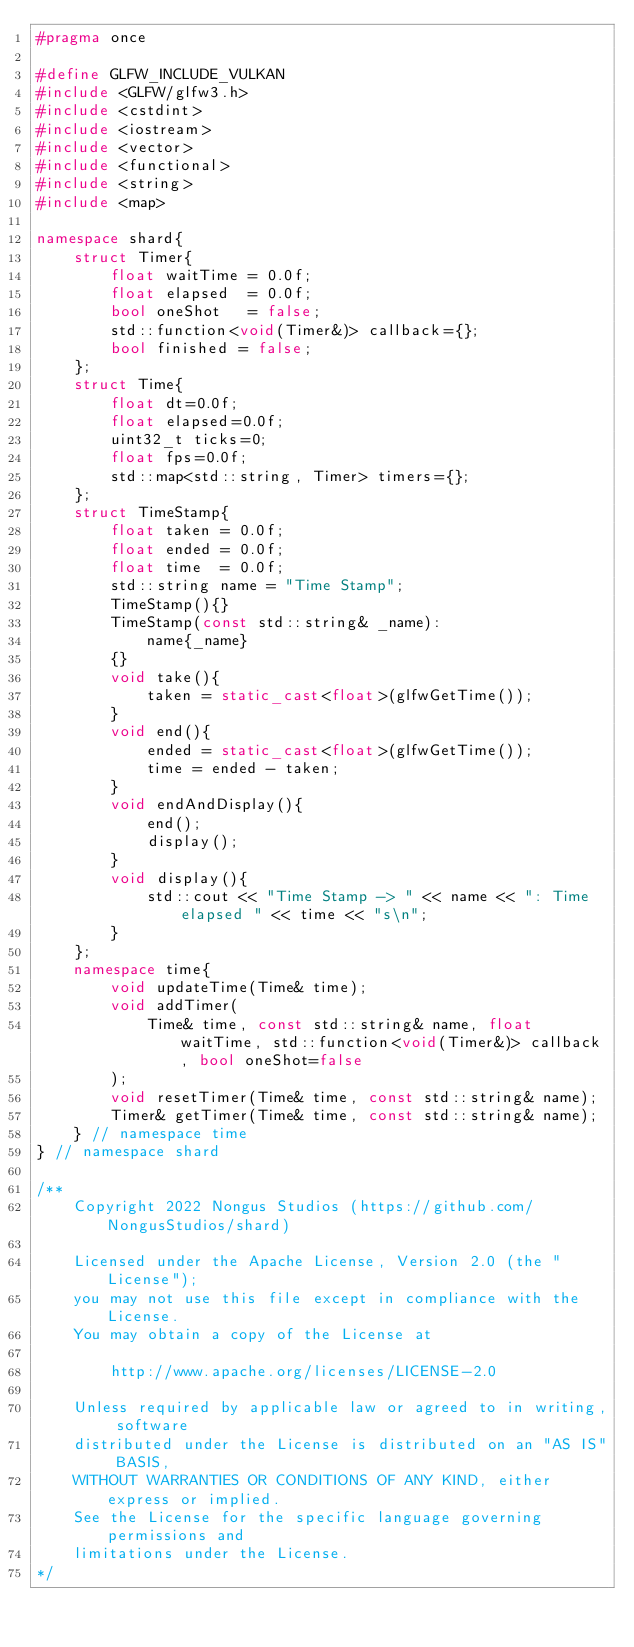Convert code to text. <code><loc_0><loc_0><loc_500><loc_500><_C++_>#pragma once

#define GLFW_INCLUDE_VULKAN
#include <GLFW/glfw3.h>
#include <cstdint>
#include <iostream>
#include <vector>
#include <functional>
#include <string>
#include <map>

namespace shard{
    struct Timer{
        float waitTime = 0.0f;
        float elapsed  = 0.0f;
        bool oneShot   = false;
        std::function<void(Timer&)> callback={};
        bool finished = false;
    };
    struct Time{
        float dt=0.0f;
        float elapsed=0.0f;
        uint32_t ticks=0;
        float fps=0.0f;
        std::map<std::string, Timer> timers={};
    };
    struct TimeStamp{
        float taken = 0.0f;
        float ended = 0.0f;
        float time  = 0.0f;
        std::string name = "Time Stamp";
        TimeStamp(){}
        TimeStamp(const std::string& _name):
            name{_name}
        {}
        void take(){
            taken = static_cast<float>(glfwGetTime());
        }
        void end(){
            ended = static_cast<float>(glfwGetTime());
            time = ended - taken;
        }
        void endAndDisplay(){
            end();
            display();
        }
        void display(){
            std::cout << "Time Stamp -> " << name << ": Time elapsed " << time << "s\n";
        }
    };
    namespace time{
        void updateTime(Time& time);
        void addTimer(
            Time& time, const std::string& name, float waitTime, std::function<void(Timer&)> callback, bool oneShot=false
        );
        void resetTimer(Time& time, const std::string& name);
        Timer& getTimer(Time& time, const std::string& name);
    } // namespace time
} // namespace shard

/**
    Copyright 2022 Nongus Studios (https://github.com/NongusStudios/shard)
    
    Licensed under the Apache License, Version 2.0 (the "License");
    you may not use this file except in compliance with the License.
    You may obtain a copy of the License at
    
        http://www.apache.org/licenses/LICENSE-2.0
    
    Unless required by applicable law or agreed to in writing, software
    distributed under the License is distributed on an "AS IS" BASIS,
    WITHOUT WARRANTIES OR CONDITIONS OF ANY KIND, either express or implied.
    See the License for the specific language governing permissions and
    limitations under the License.
*/</code> 